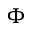Convert formula to latex. <formula><loc_0><loc_0><loc_500><loc_500>\Phi</formula> 